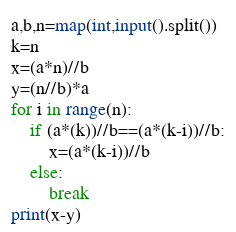<code> <loc_0><loc_0><loc_500><loc_500><_Python_>a,b,n=map(int,input().split())
k=n
x=(a*n)//b
y=(n//b)*a
for i in range(n):
    if (a*(k))//b==(a*(k-i))//b:
        x=(a*(k-i))//b
    else:
        break
print(x-y)</code> 